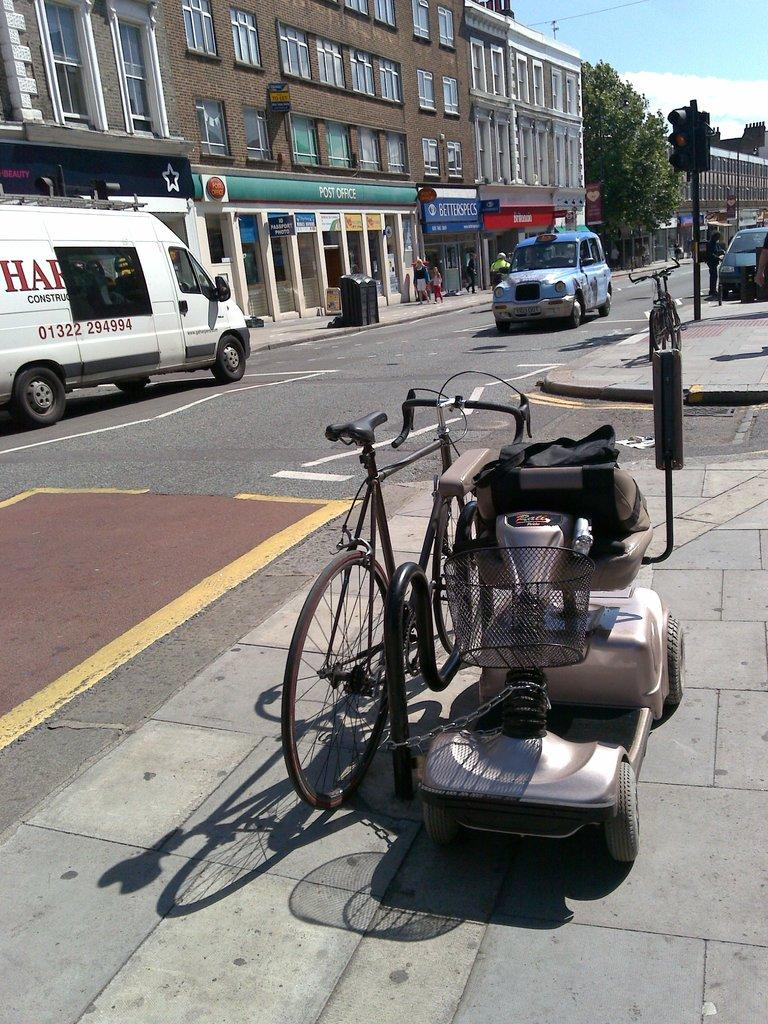<image>
Write a terse but informative summary of the picture. A motorized scooter and bicycle are chained securely to a post next to a street with a beauty store and post office. 